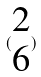Convert formula to latex. <formula><loc_0><loc_0><loc_500><loc_500>( \begin{matrix} 2 \\ 6 \end{matrix} )</formula> 